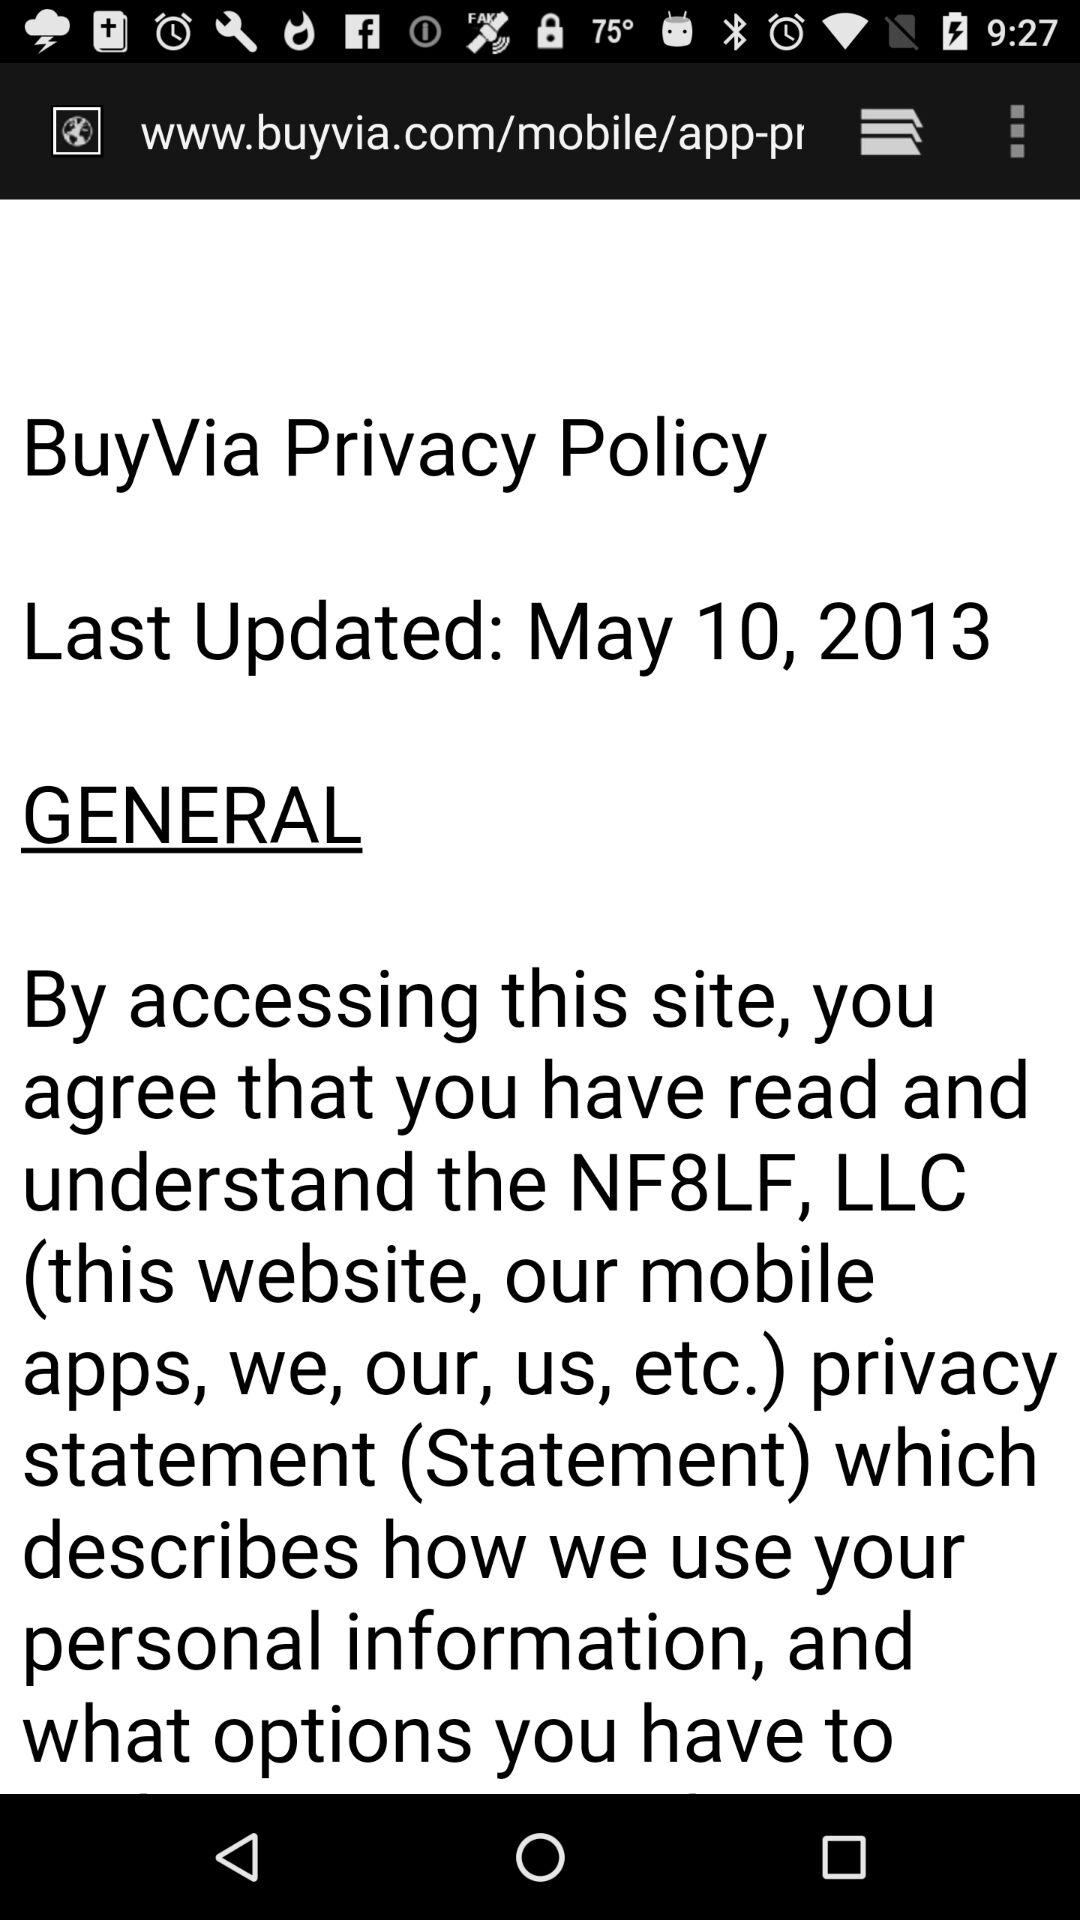What is the name of the application? The name of the application is "BuyVia". 